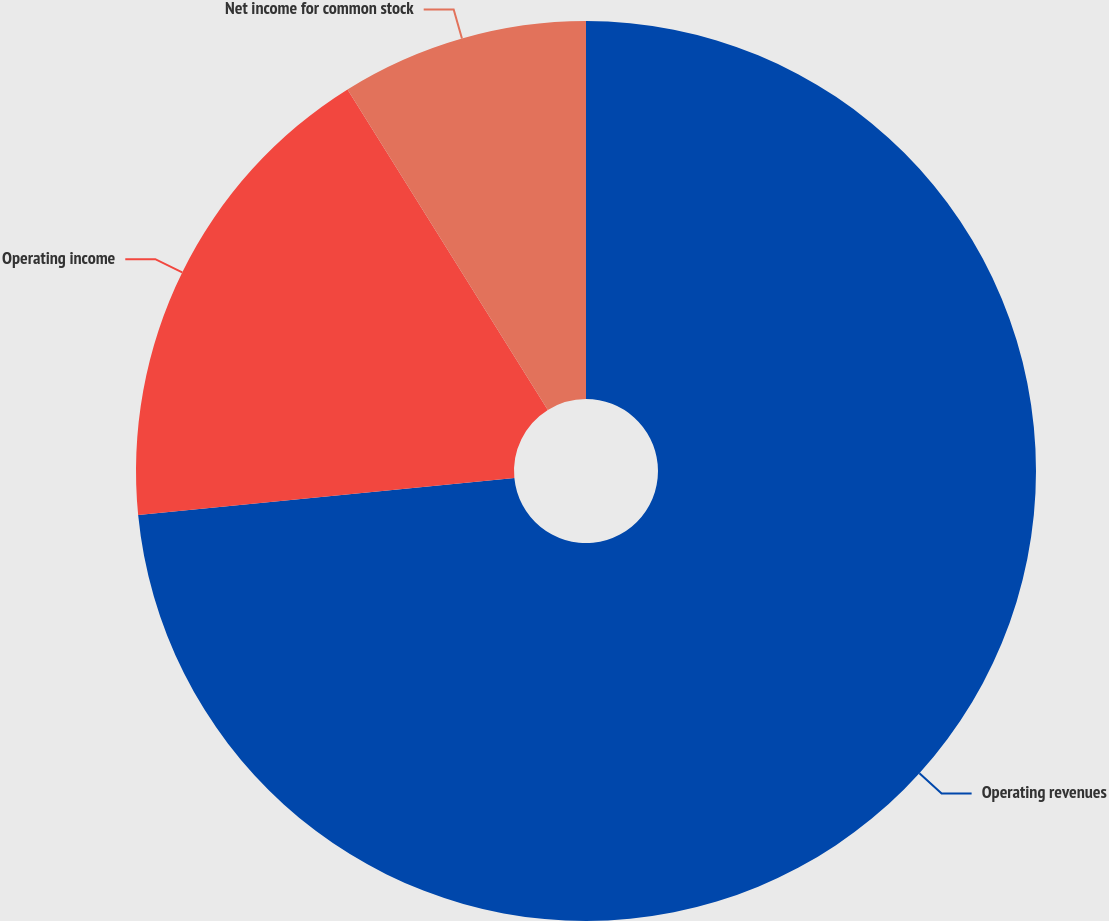Convert chart. <chart><loc_0><loc_0><loc_500><loc_500><pie_chart><fcel>Operating revenues<fcel>Operating income<fcel>Net income for common stock<nl><fcel>73.44%<fcel>17.67%<fcel>8.89%<nl></chart> 